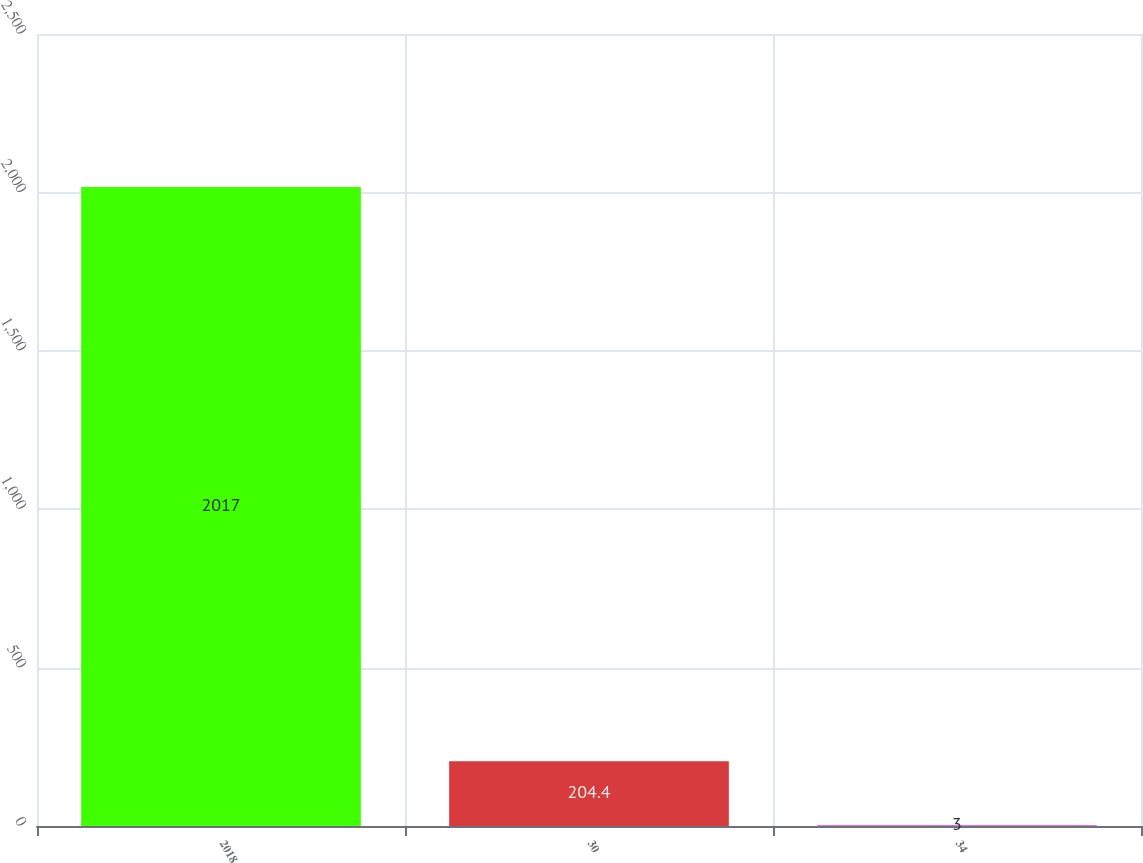<chart> <loc_0><loc_0><loc_500><loc_500><bar_chart><fcel>2018<fcel>30<fcel>34<nl><fcel>2017<fcel>204.4<fcel>3<nl></chart> 